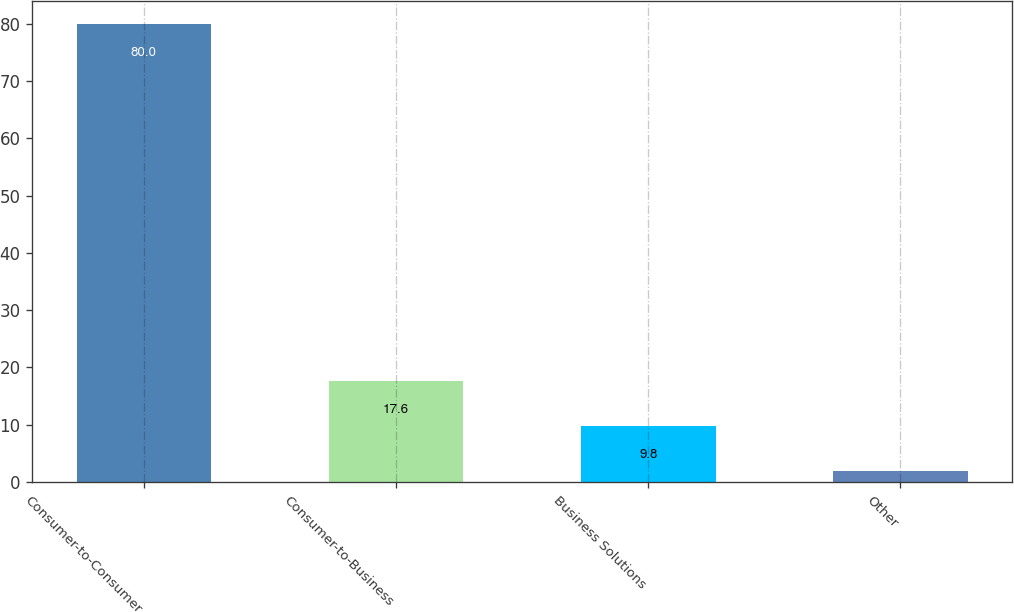Convert chart. <chart><loc_0><loc_0><loc_500><loc_500><bar_chart><fcel>Consumer-to-Consumer<fcel>Consumer-to-Business<fcel>Business Solutions<fcel>Other<nl><fcel>80<fcel>17.6<fcel>9.8<fcel>2<nl></chart> 